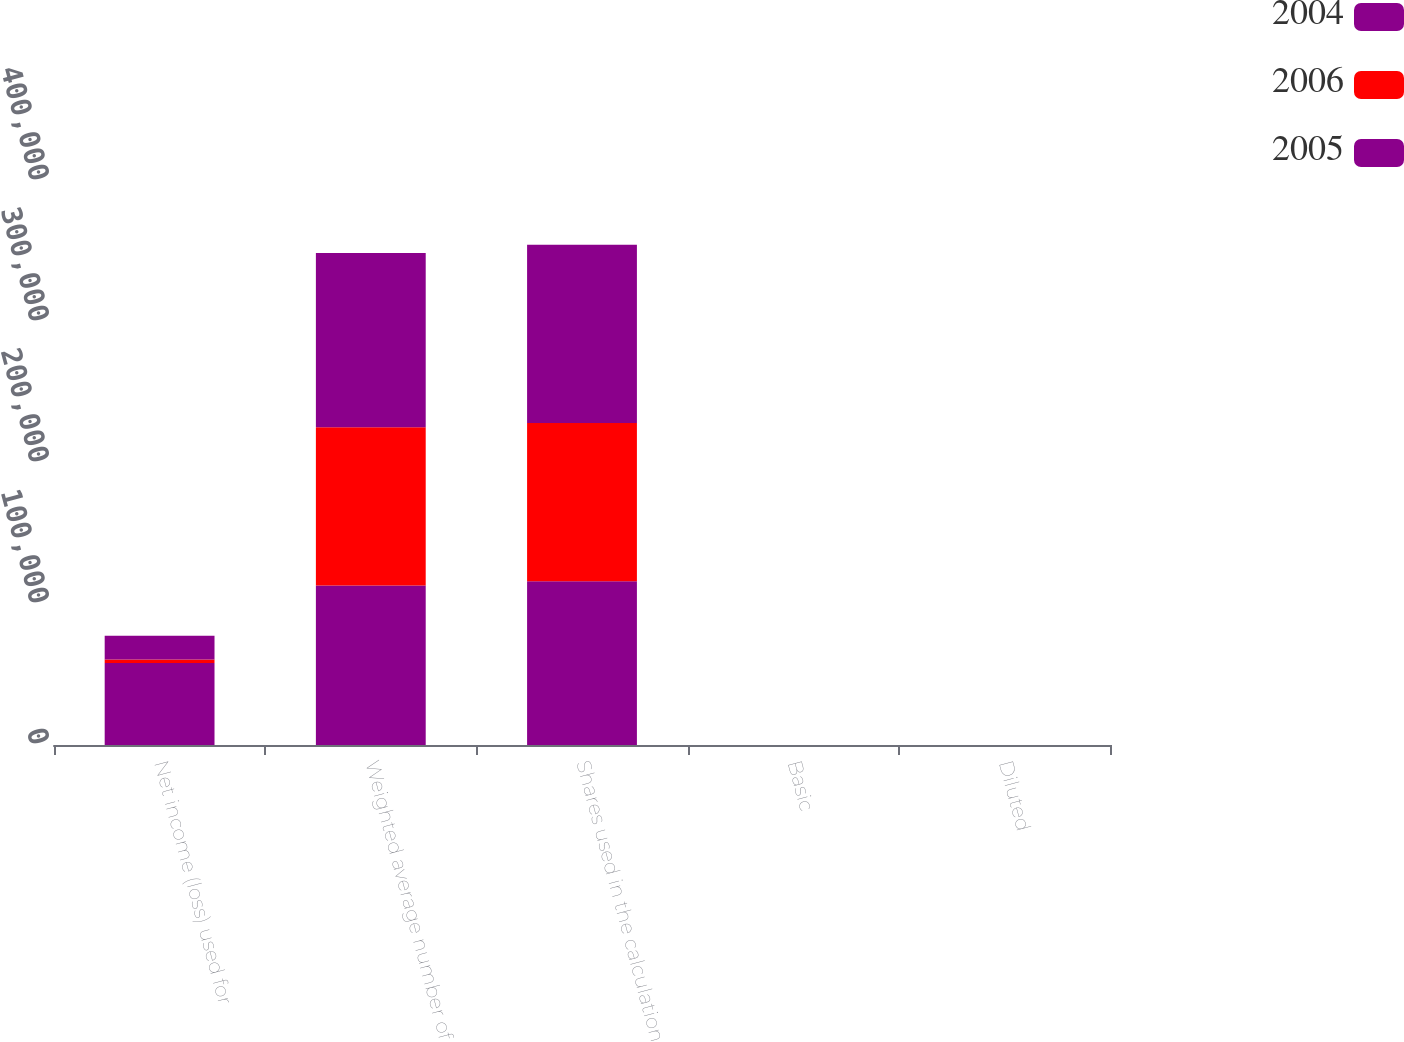<chart> <loc_0><loc_0><loc_500><loc_500><stacked_bar_chart><ecel><fcel>Net income (loss) used for<fcel>Weighted average number of<fcel>Shares used in the calculation<fcel>Basic<fcel>Diluted<nl><fcel>2004<fcel>58192<fcel>113071<fcel>116203<fcel>0.51<fcel>0.5<nl><fcel>2006<fcel>2437<fcel>112253<fcel>112253<fcel>0.02<fcel>0.02<nl><fcel>2005<fcel>16889<fcel>123603<fcel>126326<fcel>0.14<fcel>0.13<nl></chart> 